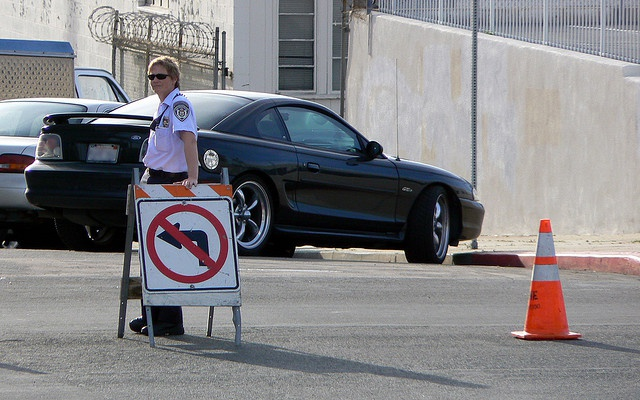Describe the objects in this image and their specific colors. I can see car in lightgray, black, navy, gray, and blue tones, people in lightgray, black, gray, and darkgray tones, car in lightgray, black, white, lightblue, and darkgray tones, and car in lightgray and darkgray tones in this image. 